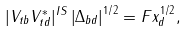Convert formula to latex. <formula><loc_0><loc_0><loc_500><loc_500>| V _ { t b } V _ { t d } ^ { * } | ^ { I S } \left | \Delta _ { b d } \right | ^ { 1 / 2 } = F x _ { d } ^ { 1 / 2 } ,</formula> 